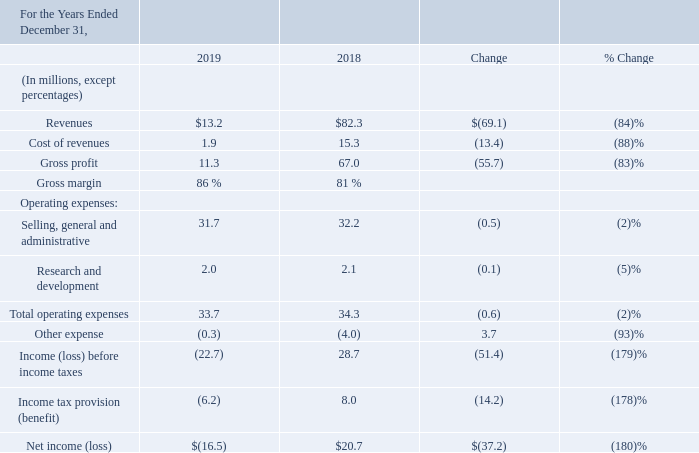Year ended December 31, 2019 compared with the year ended December 31, 2018:
Revenue in 2019 is derived from license agreements that we entered into with third-parties following negotiations pursuant to our patent licensing and enforcement program. The revenue decrease is primarily due to timing of revenues, as further described in "Item 1. Business" - "Licensing and Enforcement - Current Activities, Post 2013".
Cost of revenues includes contingent legal fees directly associated with our licensing and enforcement programs. Cost of revenues primarily decreased in proportion to the decrease in revenues.
Operating expenses consists of sales and marketing, general and administrative, and research and development. Selling, general and administrative expenses ("SG&A") consisted primarily of legal fees incurred in operations and employee headcount related expenses. These comprise approximately 60% of total SG&A expense. Litigation expenses increased $3.0 million to $19.4 million in 2019 compared to 2018 and are primarily due to the timing of various outstanding litigation actions. See "Item 3. Legal Proceedings". Employee headcount related expenses decreased $2.0 million to $3.6 million in 2019 compared to 2018, primarily due to lower incentive bonuses.
Research and development expense remained flat between years.
Other expense decreased in 2019 as we no longer have exposure from the warrant liability, and included $0.7 million related to the sale of our investment in JVP, offset by $0.3 million of net interest income.
Income tax provision (benefit) is primarily a function of income (loss) before income, state income tax expense (benefit) and federal benefit of foreign derived intangible tax benefit related to 2018.
Where is revenue in 2019 derived from? License agreements that we entered into with third-parties following negotiations pursuant to our patent licensing and enforcement program. How much is litigation expenses in 2019 and what was the increase in litigation expenses between 2018 and 2019? $19.4 million, $3.0 million. What does cost of revenues comprise? Contingent legal fees directly associated with our licensing and enforcement programs. What is the percentage change in revenue between 2018 and 2019?
Answer scale should be: percent. (13.2-82.3)/82.3 
Answer: -83.96. What is the value of litigation expenses in 2019 as a percentage of the 2019 gross profit?
Answer scale should be: percent. 19.4/11.3 
Answer: 171.68. What is the value of employee headcount related expenses as a percentage of the cost of revenues in 2019?
Answer scale should be: percent. 3.6/1.9 
Answer: 189.47. 